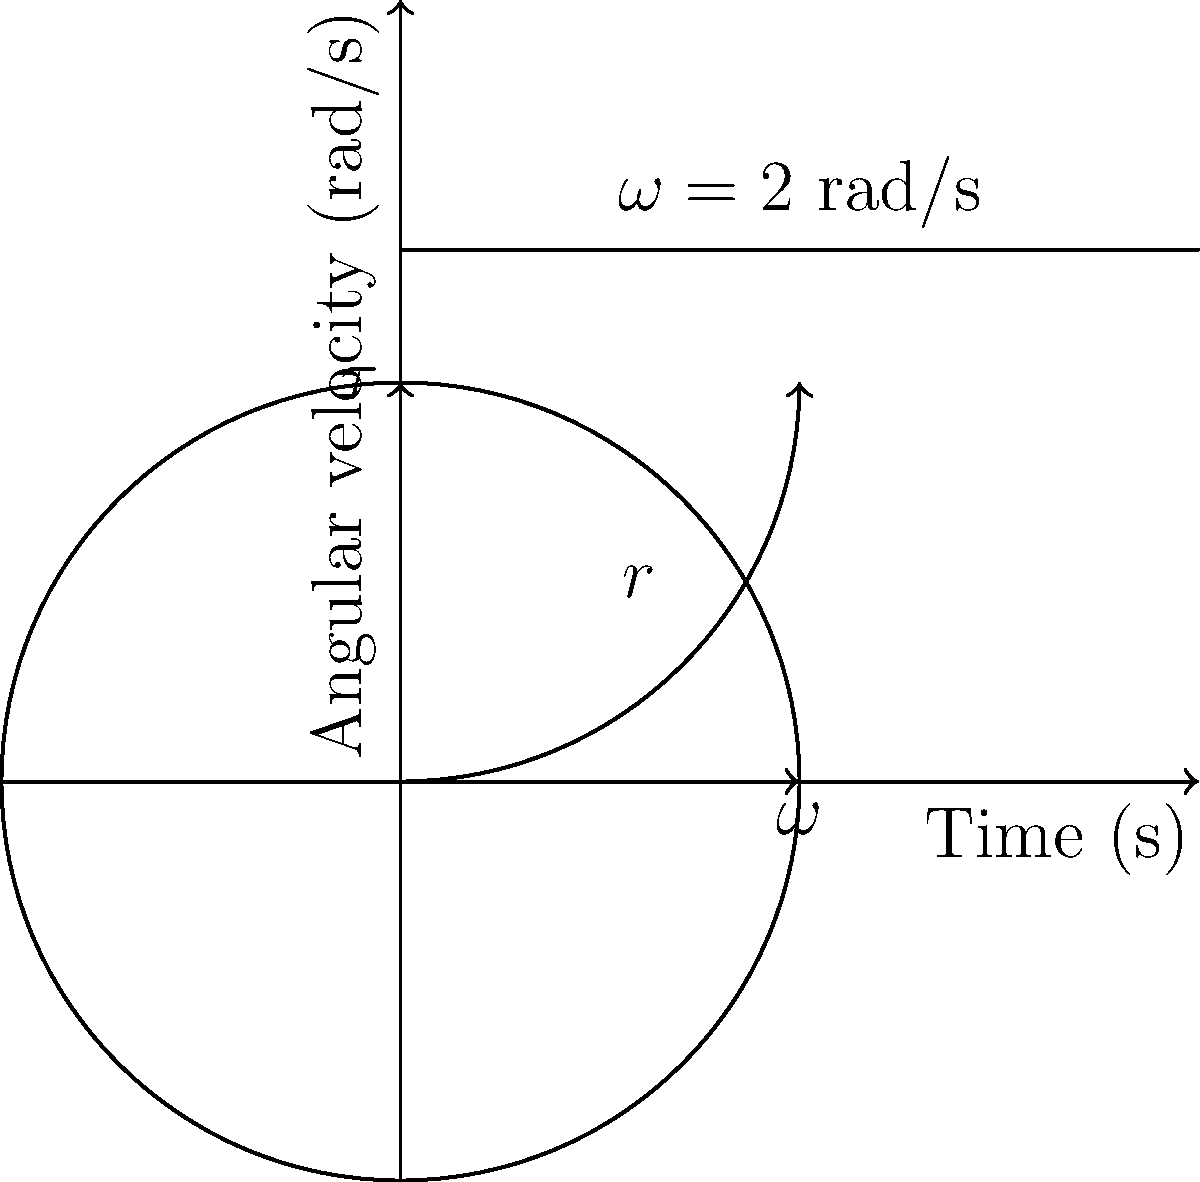As a film projectionist, you're working with a classic Sri Lankan thriller film reel. The reel has a radius $r = 0.15$ m and is rotating at a constant angular velocity $\omega = 2$ rad/s, as shown in the diagram. If a constant torque $\tau = 0.3$ N·m is applied to the reel for 3 seconds, what is the final angular velocity of the reel? To solve this problem, we'll use the rotational form of Newton's Second Law and the concept of angular acceleration. Let's break it down step by step:

1) The rotational form of Newton's Second Law is:
   $$\tau = I\alpha$$
   where $\tau$ is torque, $I$ is moment of inertia, and $\alpha$ is angular acceleration.

2) For a solid disk (which we'll assume the film reel is), the moment of inertia is:
   $$I = \frac{1}{2}mr^2$$
   where $m$ is the mass of the reel and $r$ is its radius.

3) We don't know the mass, but we can find $\alpha$ using the given information:
   $$\alpha = \frac{\tau}{I} = \frac{2\tau}{mr^2}$$

4) The change in angular velocity is given by:
   $$\Delta\omega = \alpha t$$
   where $t$ is the time the torque is applied.

5) Substituting the known values:
   $$\Delta\omega = \frac{2\tau}{mr^2} \cdot t = \frac{2 \cdot 0.3}{m \cdot 0.15^2} \cdot 3 = \frac{12}{m}$$

6) The final angular velocity is:
   $$\omega_f = \omega_i + \Delta\omega = 2 + \frac{12}{m}$$

7) We don't know the mass $m$, but we know that the final angular velocity must be greater than the initial velocity of 2 rad/s.
Answer: $\omega_f = 2 + \frac{12}{m}$ rad/s, where $m$ is the unknown mass of the reel in kg. 